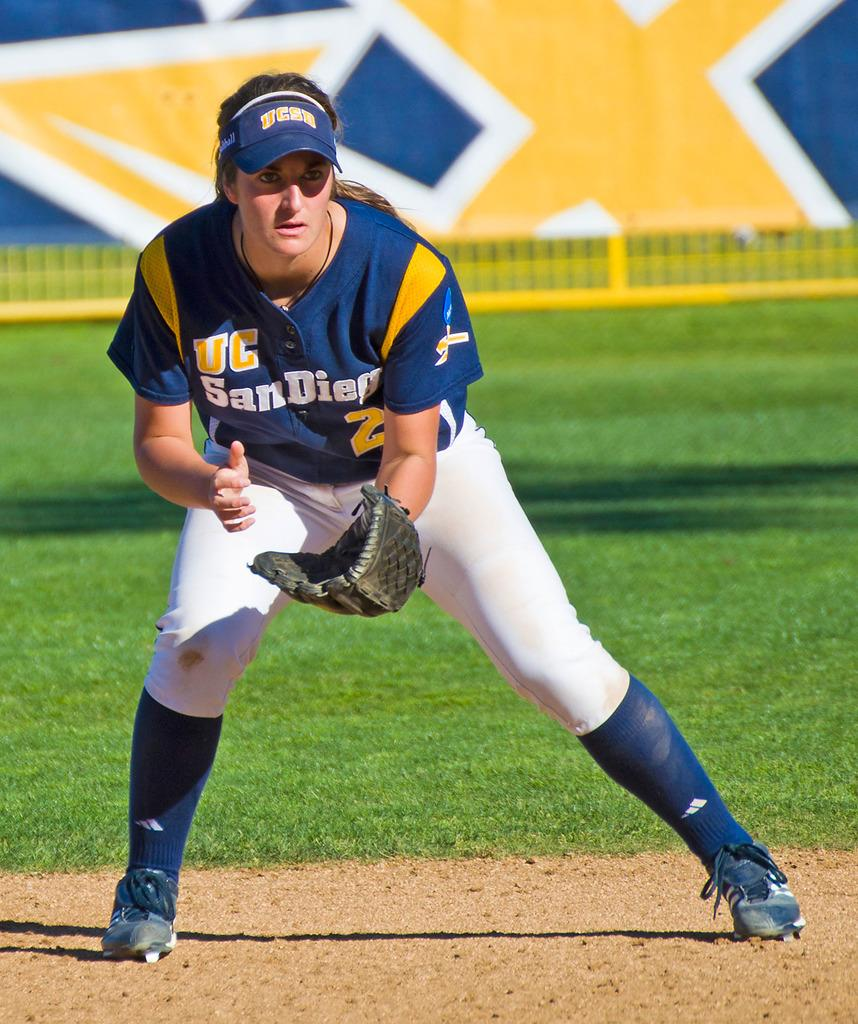Who is the main subject in the image? There is a woman in the image. What is the woman standing on? The woman is standing on land with grass. What is the woman wearing on her head? The woman is wearing a cap. What can be seen at the top of the image? There is a banner at the top of the image. What sound can be heard coming from the woman's cap in the image? There is no sound coming from the woman's cap in the image. 